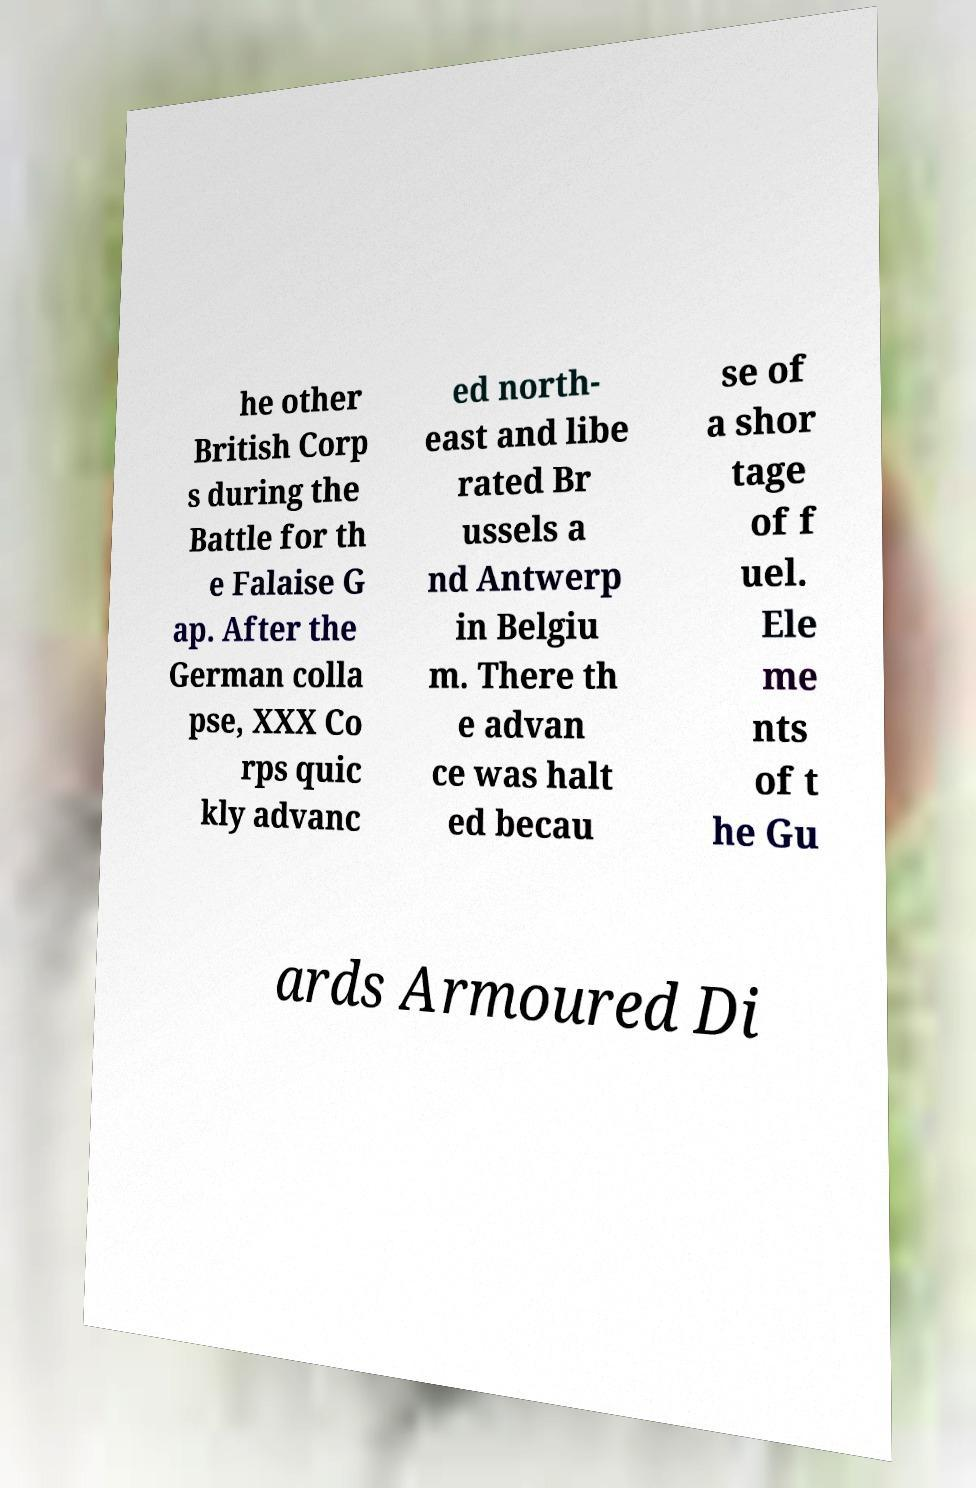Could you extract and type out the text from this image? he other British Corp s during the Battle for th e Falaise G ap. After the German colla pse, XXX Co rps quic kly advanc ed north- east and libe rated Br ussels a nd Antwerp in Belgiu m. There th e advan ce was halt ed becau se of a shor tage of f uel. Ele me nts of t he Gu ards Armoured Di 